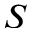Convert formula to latex. <formula><loc_0><loc_0><loc_500><loc_500>S</formula> 